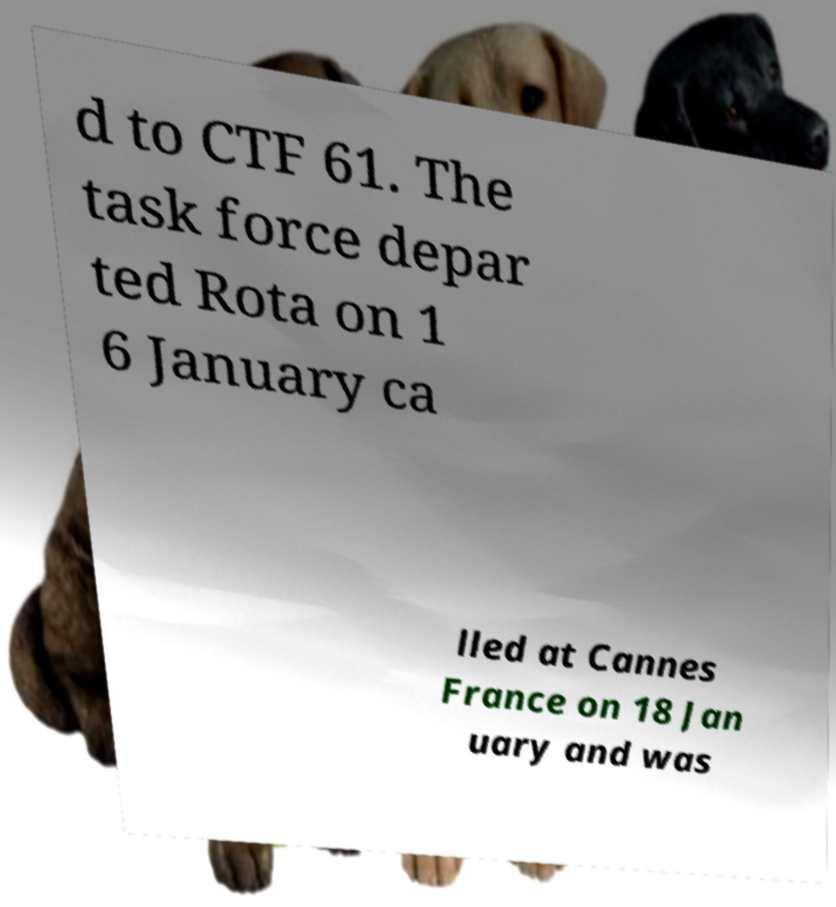Could you extract and type out the text from this image? d to CTF 61. The task force depar ted Rota on 1 6 January ca lled at Cannes France on 18 Jan uary and was 